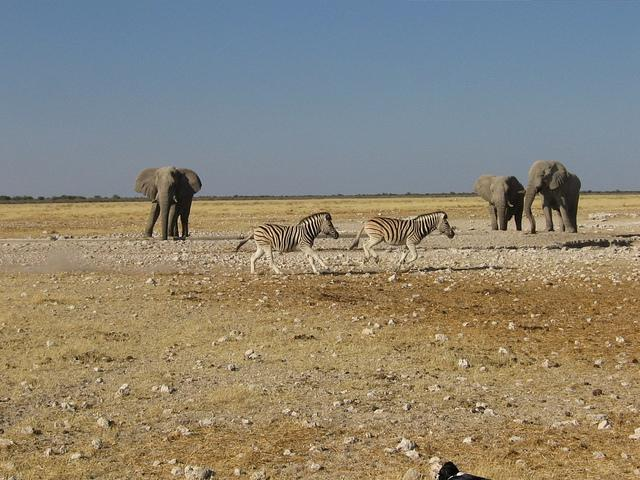How many zebras are running across the rocky field? two 